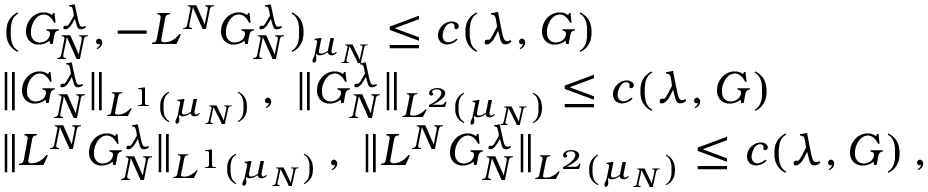<formula> <loc_0><loc_0><loc_500><loc_500>\begin{array} { r l } & { ( G _ { N } ^ { \lambda } , - L ^ { N } G _ { N } ^ { \lambda } ) _ { \mu _ { N } } \leq c ( \lambda , G ) } \\ & { \| G _ { N } ^ { \lambda } \| _ { L ^ { 1 } ( \mu _ { N } ) } \, , \, \| G _ { N } ^ { \lambda } \| _ { L ^ { 2 } ( \mu _ { N } ) } \leq c ( \lambda , G ) } \\ & { \| L ^ { N } G _ { N } ^ { \lambda } \| _ { L ^ { 1 } ( \mu _ { N } ) } \, , \, \| L ^ { N } G _ { N } ^ { \lambda } \| _ { L ^ { 2 } ( \mu _ { N } ) } \leq c ( \lambda , G ) \, , } \end{array}</formula> 